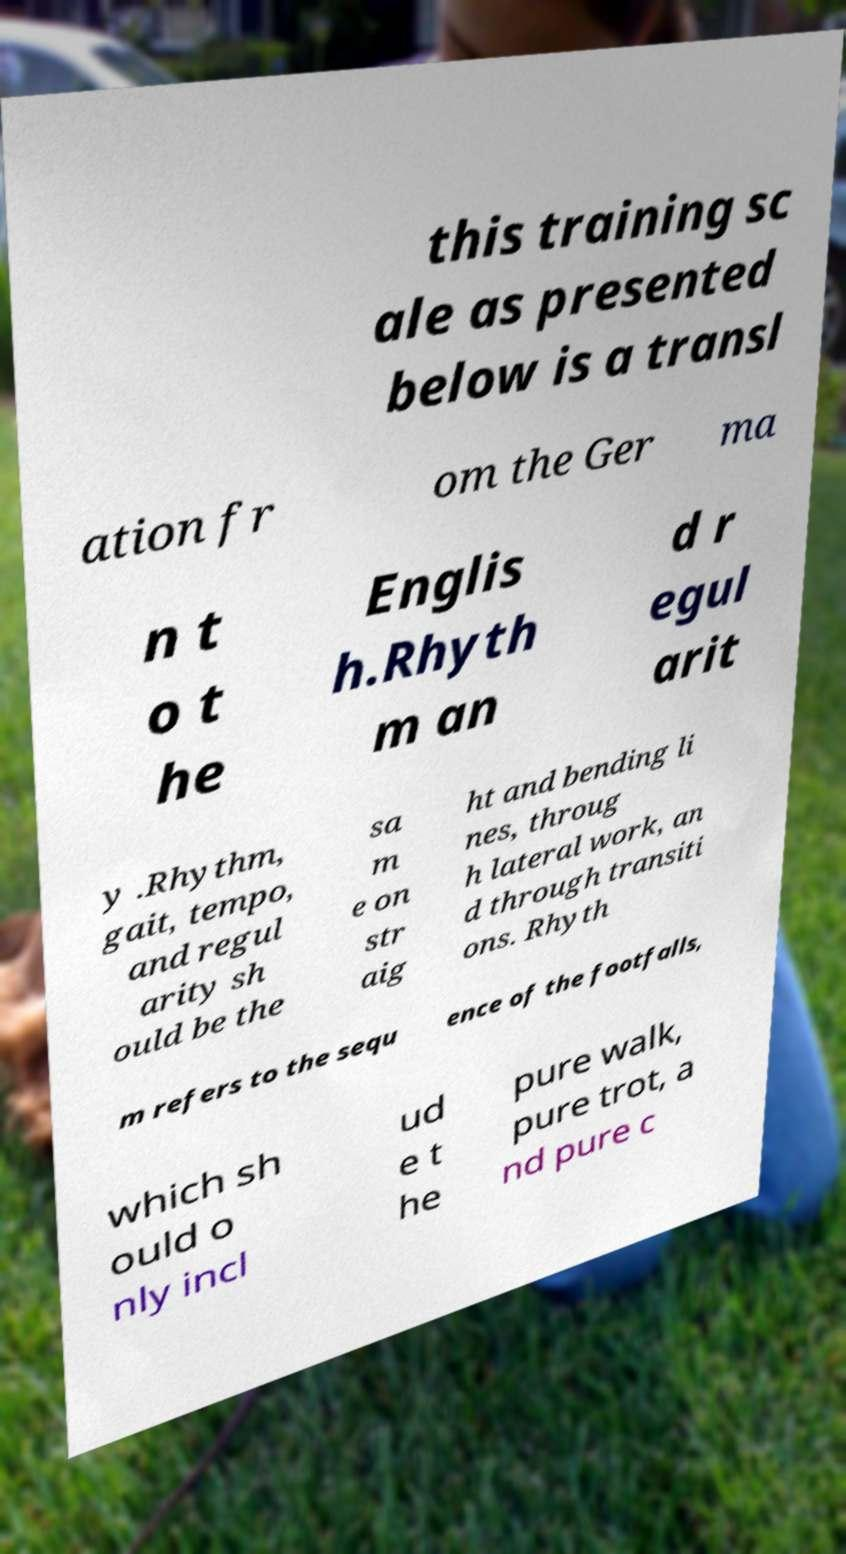There's text embedded in this image that I need extracted. Can you transcribe it verbatim? this training sc ale as presented below is a transl ation fr om the Ger ma n t o t he Englis h.Rhyth m an d r egul arit y .Rhythm, gait, tempo, and regul arity sh ould be the sa m e on str aig ht and bending li nes, throug h lateral work, an d through transiti ons. Rhyth m refers to the sequ ence of the footfalls, which sh ould o nly incl ud e t he pure walk, pure trot, a nd pure c 